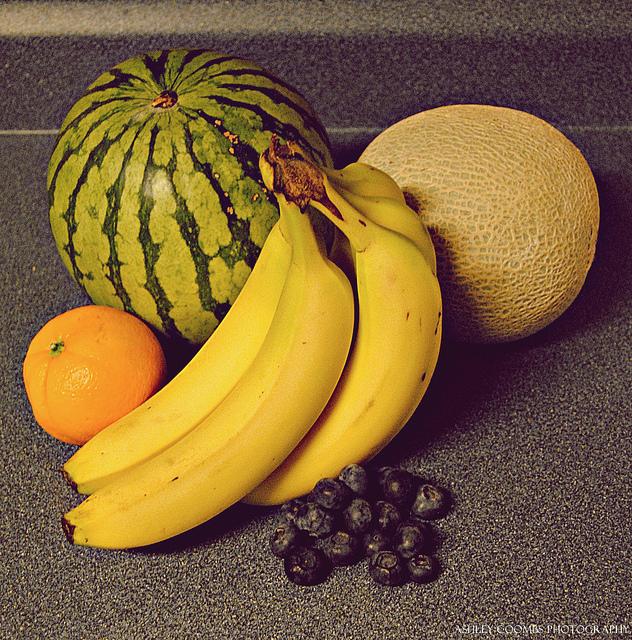How many types of fruits are there?
Short answer required. 5. How many bananas are on the counter?
Be succinct. 5. Would a vegetarian eat these foods?
Give a very brief answer. Yes. How many oranges are there?
Concise answer only. 1. How many of these fruits have to be cut before being eaten?
Keep it brief. 2. 